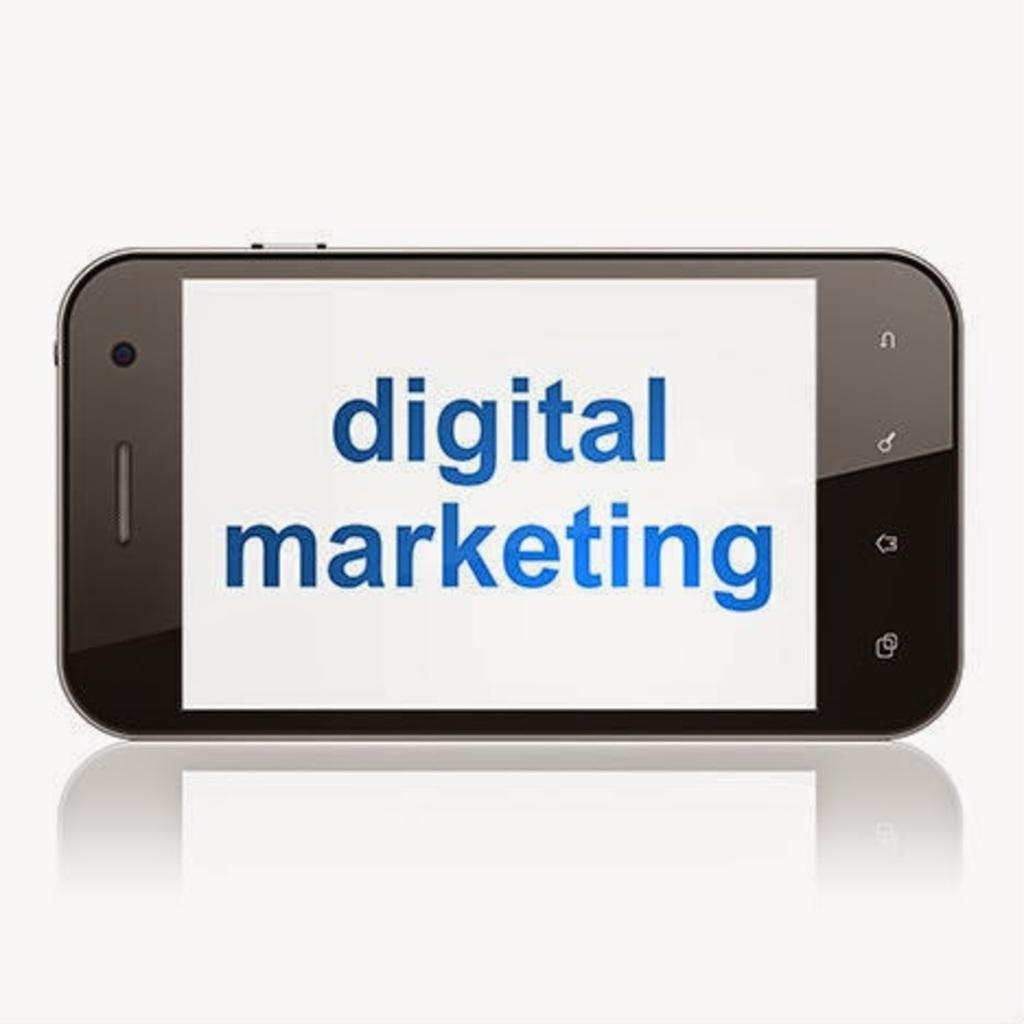<image>
Relay a brief, clear account of the picture shown. a cell phone reads Digital Marketing is displayed on a white background 